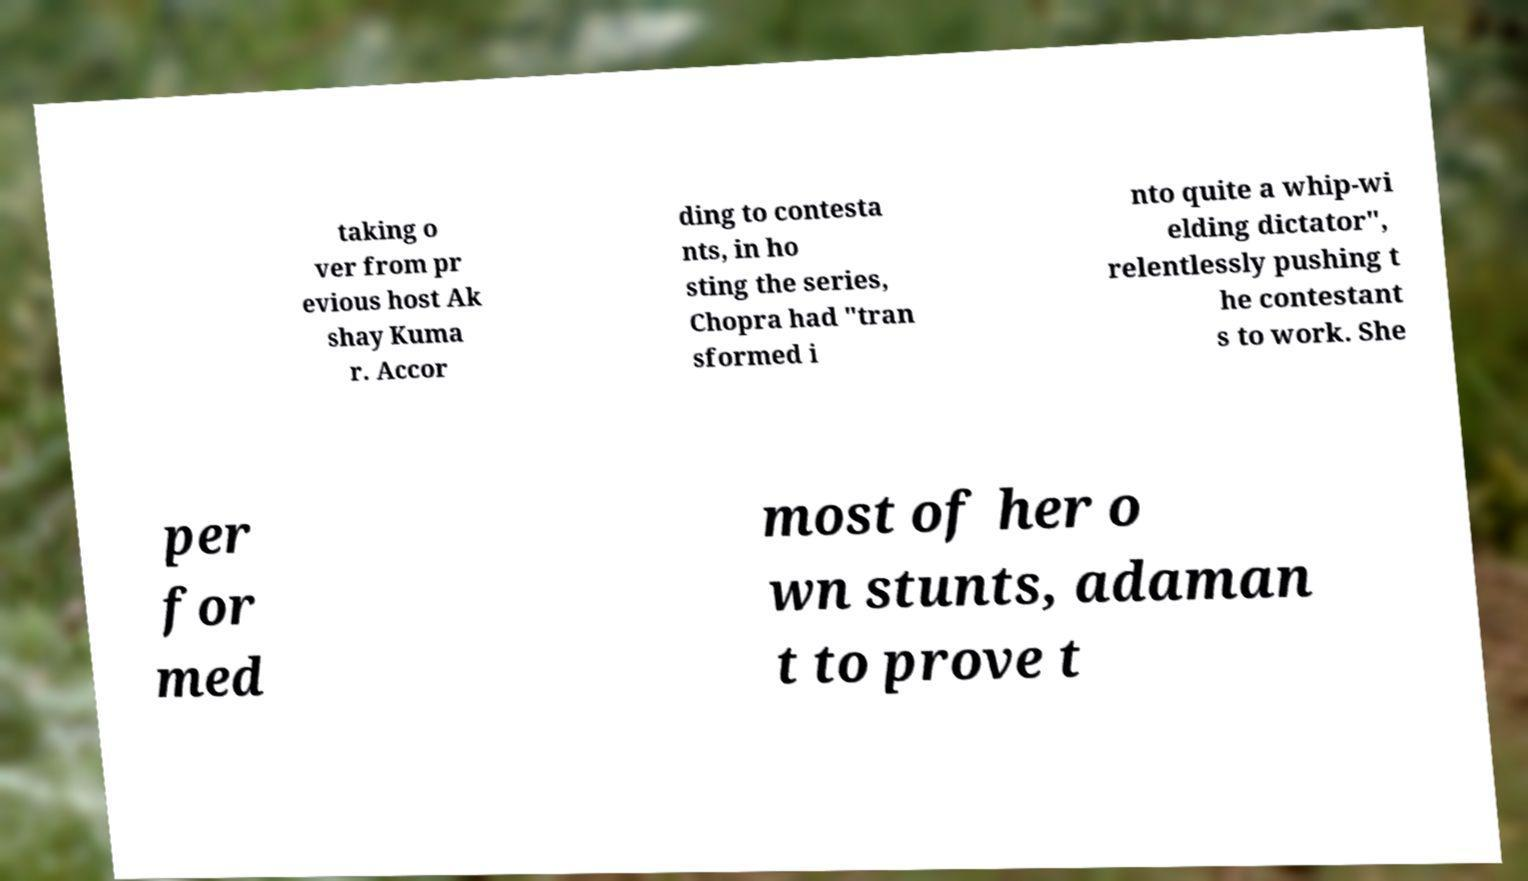For documentation purposes, I need the text within this image transcribed. Could you provide that? taking o ver from pr evious host Ak shay Kuma r. Accor ding to contesta nts, in ho sting the series, Chopra had "tran sformed i nto quite a whip-wi elding dictator", relentlessly pushing t he contestant s to work. She per for med most of her o wn stunts, adaman t to prove t 